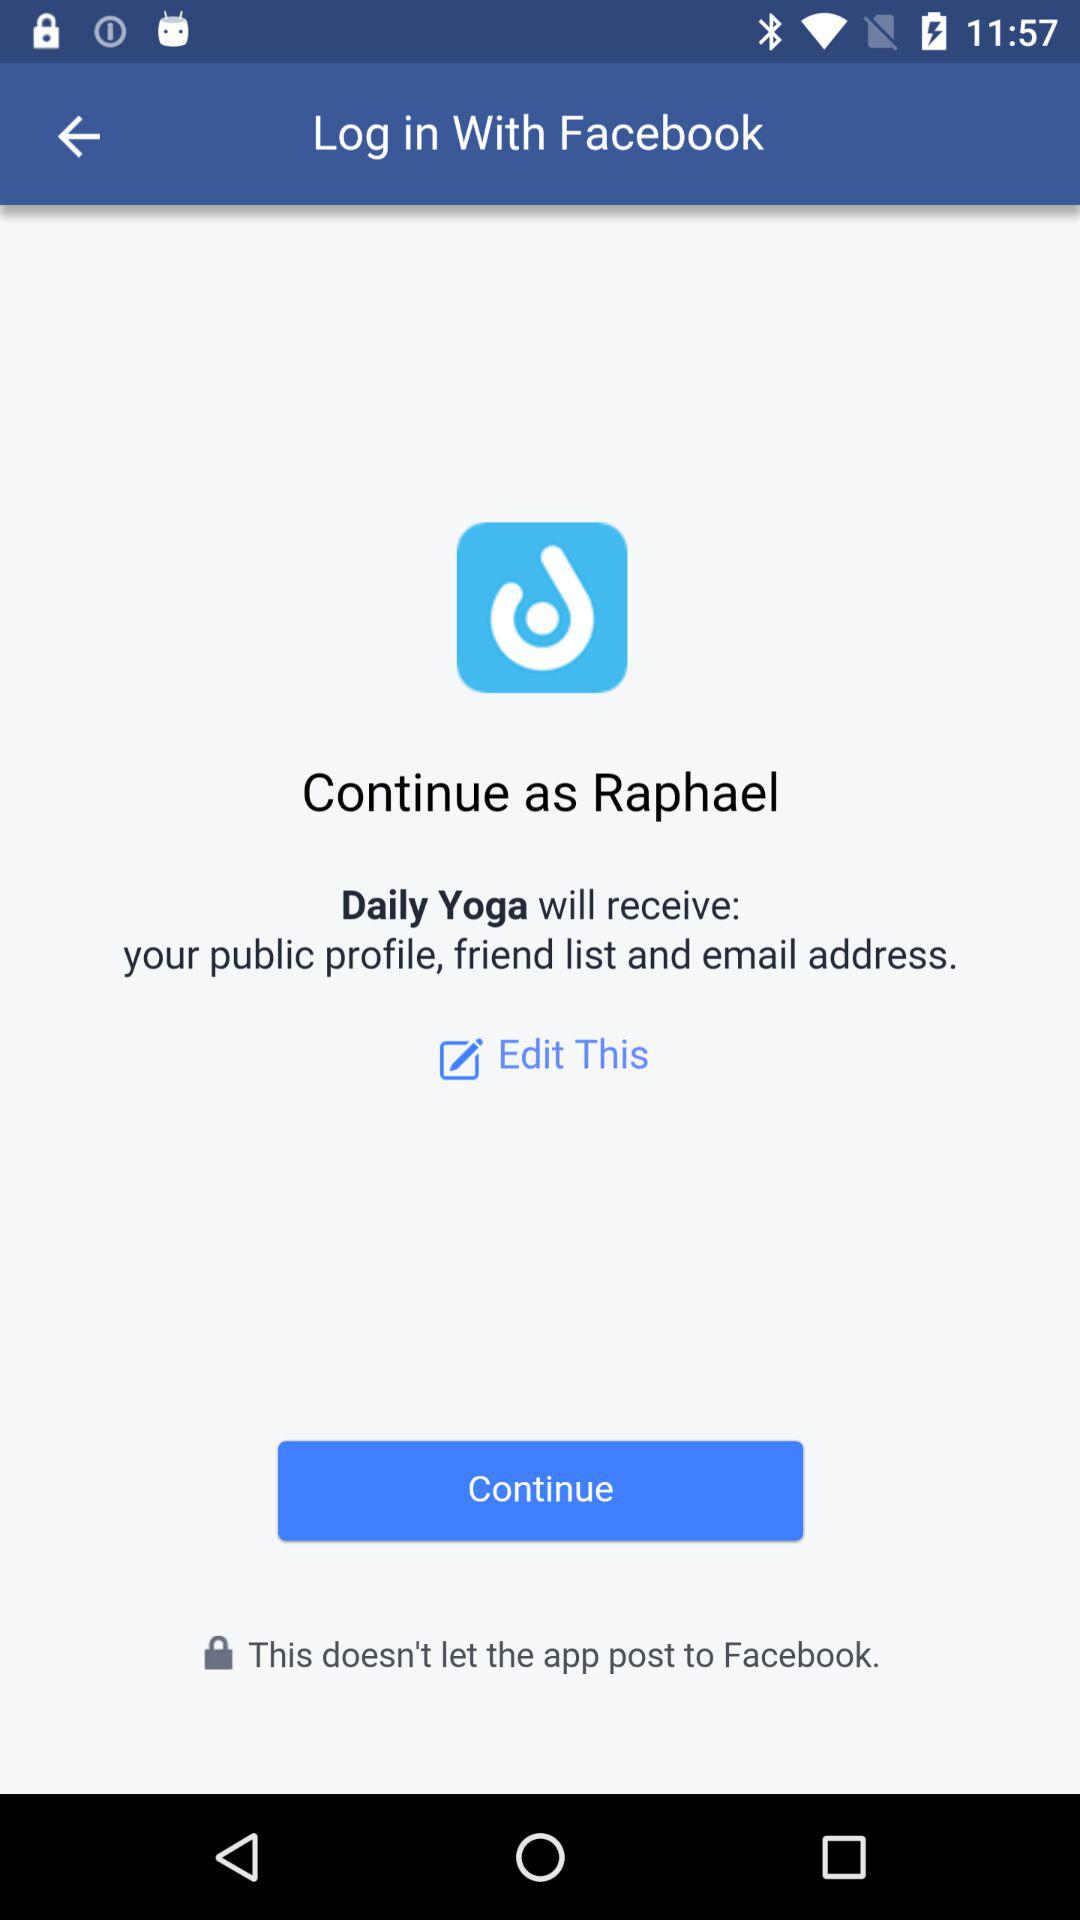Which option is selected?
When the provided information is insufficient, respond with <no answer>. <no answer> 